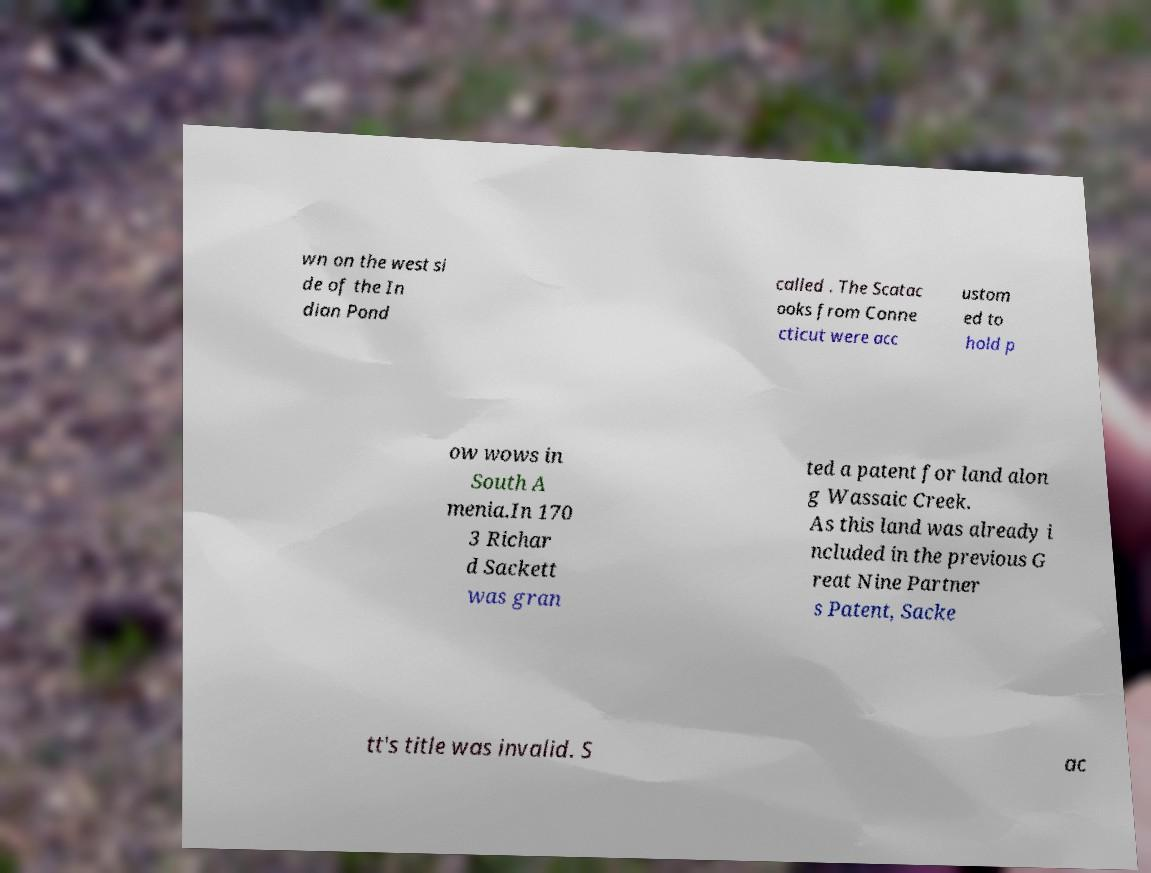Please read and relay the text visible in this image. What does it say? wn on the west si de of the In dian Pond called . The Scatac ooks from Conne cticut were acc ustom ed to hold p ow wows in South A menia.In 170 3 Richar d Sackett was gran ted a patent for land alon g Wassaic Creek. As this land was already i ncluded in the previous G reat Nine Partner s Patent, Sacke tt's title was invalid. S ac 